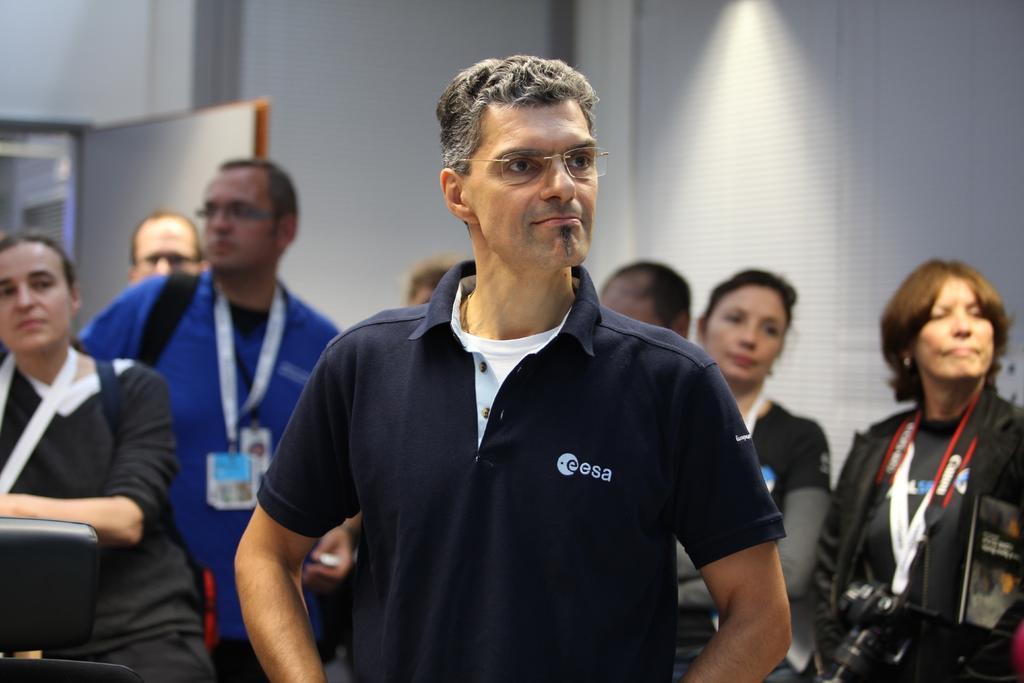Could you give a brief overview of what you see in this image? A man is standing wearing spectacles and a blue t shirt. There are other people at the back wearing id card. There is a door at the left. 